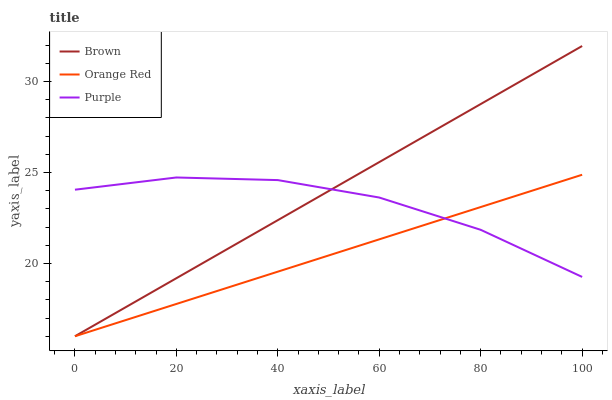Does Orange Red have the minimum area under the curve?
Answer yes or no. Yes. Does Brown have the maximum area under the curve?
Answer yes or no. Yes. Does Brown have the minimum area under the curve?
Answer yes or no. No. Does Orange Red have the maximum area under the curve?
Answer yes or no. No. Is Orange Red the smoothest?
Answer yes or no. Yes. Is Purple the roughest?
Answer yes or no. Yes. Is Brown the smoothest?
Answer yes or no. No. Is Brown the roughest?
Answer yes or no. No. Does Brown have the highest value?
Answer yes or no. Yes. Does Orange Red have the highest value?
Answer yes or no. No. Does Orange Red intersect Purple?
Answer yes or no. Yes. Is Orange Red less than Purple?
Answer yes or no. No. Is Orange Red greater than Purple?
Answer yes or no. No. 